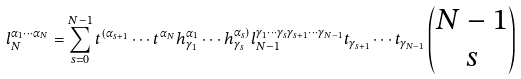<formula> <loc_0><loc_0><loc_500><loc_500>l ^ { \alpha _ { 1 } \cdots \alpha _ { N } } _ { N } = \sum _ { s = 0 } ^ { N - 1 } t ^ { ( \alpha _ { s + 1 } } \cdots t ^ { \alpha _ { N } } h ^ { \alpha _ { 1 } } _ { \gamma _ { 1 } } \cdots h ^ { \alpha _ { s } ) } _ { \gamma _ { s } } l ^ { \gamma _ { 1 } \cdots \gamma _ { s } \gamma _ { s + 1 } \cdots \gamma _ { N - 1 } } _ { N - 1 } t _ { \gamma _ { s + 1 } } \cdots t _ { \gamma _ { N - 1 } } \begin{pmatrix} N - 1 \\ s \end{pmatrix}</formula> 